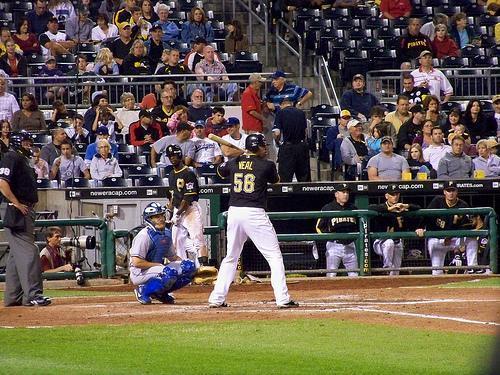How many bats are there?
Give a very brief answer. 1. 